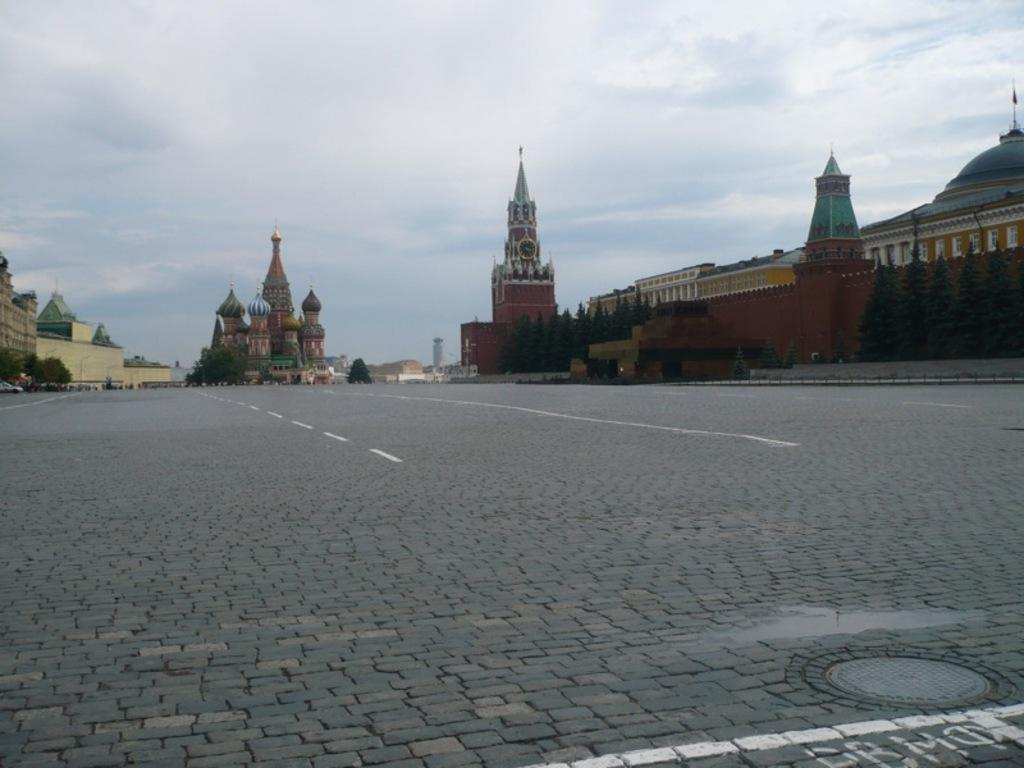What is the main feature of the image? There is a road in the image. Can you describe the road in more detail? The road has white color lines. What can be seen in the background of the image? There are buildings, trees, and clouds in the sky in the background of the image. How many goose feathers can be seen on the road in the image? There are no goose feathers visible on the road in the image. What type of trains are passing by on the road in the image? There are no trains present in the image; it features a road with white color lines. 